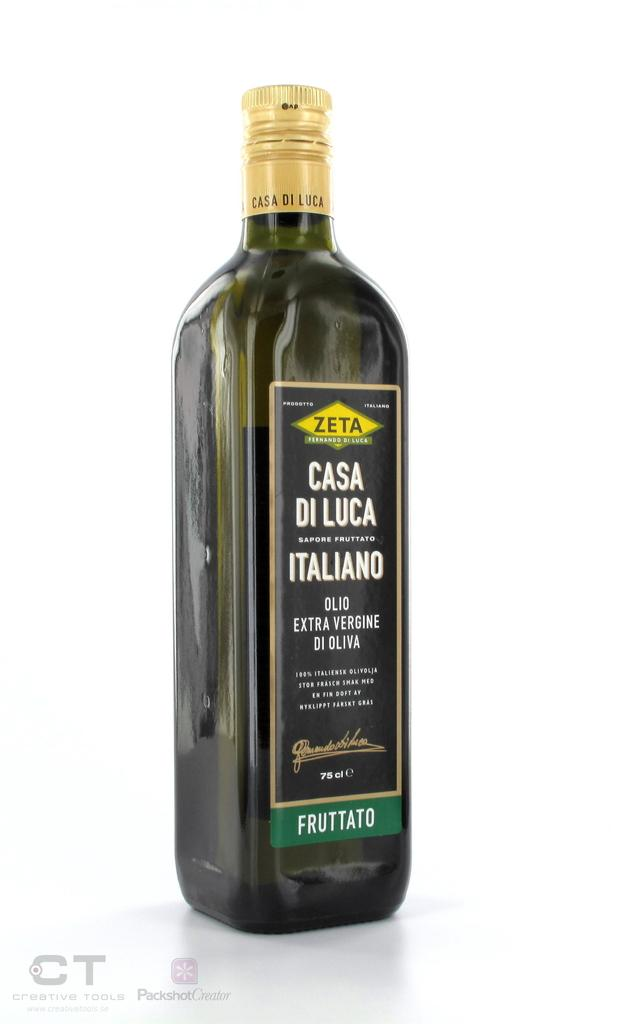<image>
Provide a brief description of the given image. Zeta casa di luca italiano olive oil in a greenish bottle with a white background. 